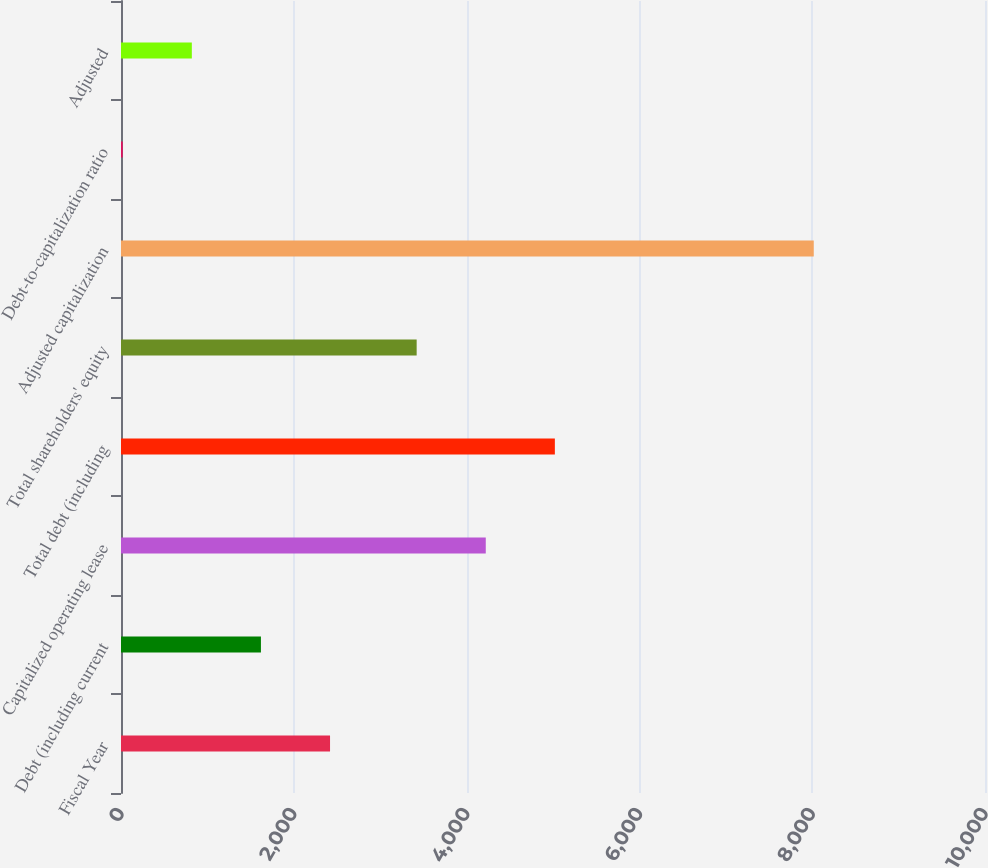<chart> <loc_0><loc_0><loc_500><loc_500><bar_chart><fcel>Fiscal Year<fcel>Debt (including current<fcel>Capitalized operating lease<fcel>Total debt (including<fcel>Total shareholders' equity<fcel>Adjusted capitalization<fcel>Debt-to-capitalization ratio<fcel>Adjusted<nl><fcel>2419.4<fcel>1619.6<fcel>4221.8<fcel>5021.6<fcel>3422<fcel>8018<fcel>20<fcel>819.8<nl></chart> 